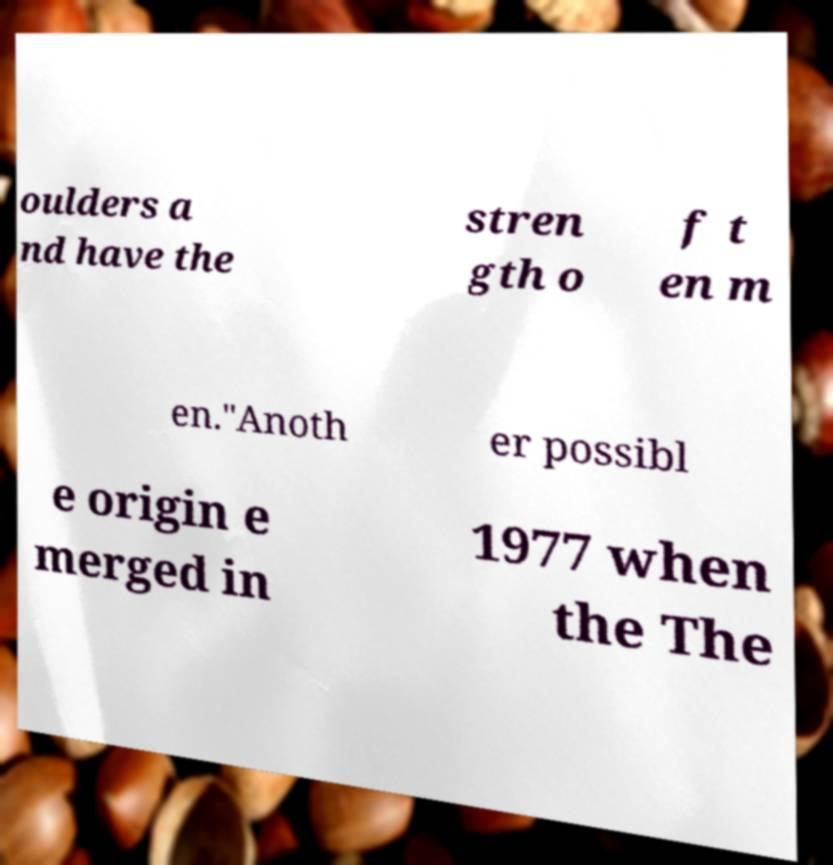Please identify and transcribe the text found in this image. oulders a nd have the stren gth o f t en m en."Anoth er possibl e origin e merged in 1977 when the The 